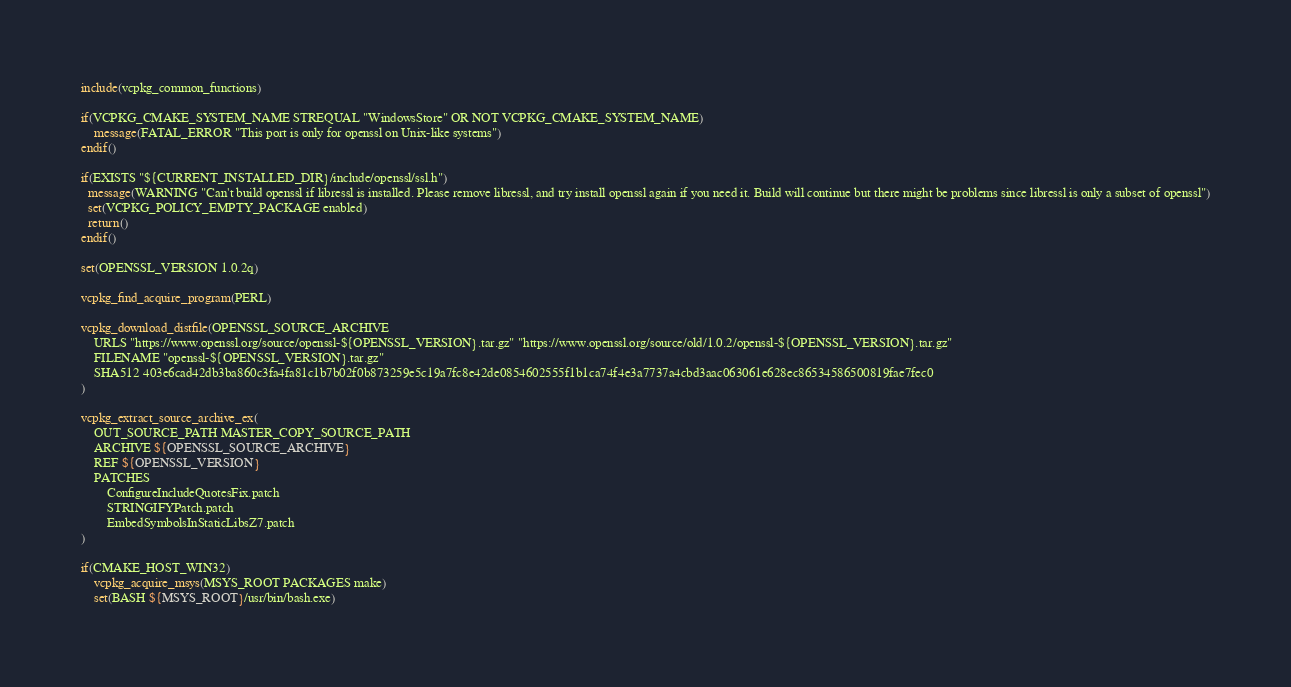<code> <loc_0><loc_0><loc_500><loc_500><_CMake_>include(vcpkg_common_functions)

if(VCPKG_CMAKE_SYSTEM_NAME STREQUAL "WindowsStore" OR NOT VCPKG_CMAKE_SYSTEM_NAME)
    message(FATAL_ERROR "This port is only for openssl on Unix-like systems")
endif()

if(EXISTS "${CURRENT_INSTALLED_DIR}/include/openssl/ssl.h")
  message(WARNING "Can't build openssl if libressl is installed. Please remove libressl, and try install openssl again if you need it. Build will continue but there might be problems since libressl is only a subset of openssl")
  set(VCPKG_POLICY_EMPTY_PACKAGE enabled)
  return()
endif()

set(OPENSSL_VERSION 1.0.2q)

vcpkg_find_acquire_program(PERL)

vcpkg_download_distfile(OPENSSL_SOURCE_ARCHIVE
    URLS "https://www.openssl.org/source/openssl-${OPENSSL_VERSION}.tar.gz" "https://www.openssl.org/source/old/1.0.2/openssl-${OPENSSL_VERSION}.tar.gz"
    FILENAME "openssl-${OPENSSL_VERSION}.tar.gz"
    SHA512 403e6cad42db3ba860c3fa4fa81c1b7b02f0b873259e5c19a7fc8e42de0854602555f1b1ca74f4e3a7737a4cbd3aac063061e628ec86534586500819fae7fec0
)

vcpkg_extract_source_archive_ex(
    OUT_SOURCE_PATH MASTER_COPY_SOURCE_PATH
    ARCHIVE ${OPENSSL_SOURCE_ARCHIVE}
    REF ${OPENSSL_VERSION}
    PATCHES
        ConfigureIncludeQuotesFix.patch
        STRINGIFYPatch.patch
        EmbedSymbolsInStaticLibsZ7.patch
)

if(CMAKE_HOST_WIN32)
    vcpkg_acquire_msys(MSYS_ROOT PACKAGES make)
    set(BASH ${MSYS_ROOT}/usr/bin/bash.exe)</code> 